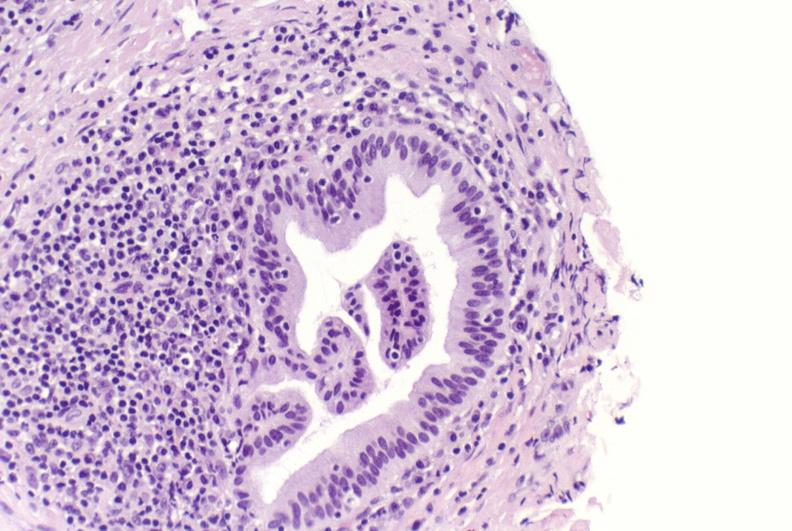what is present?
Answer the question using a single word or phrase. Hepatobiliary 